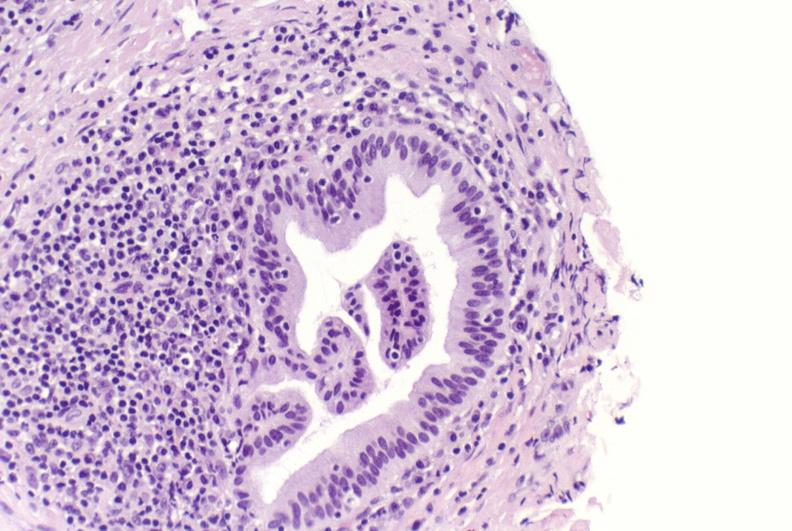what is present?
Answer the question using a single word or phrase. Hepatobiliary 